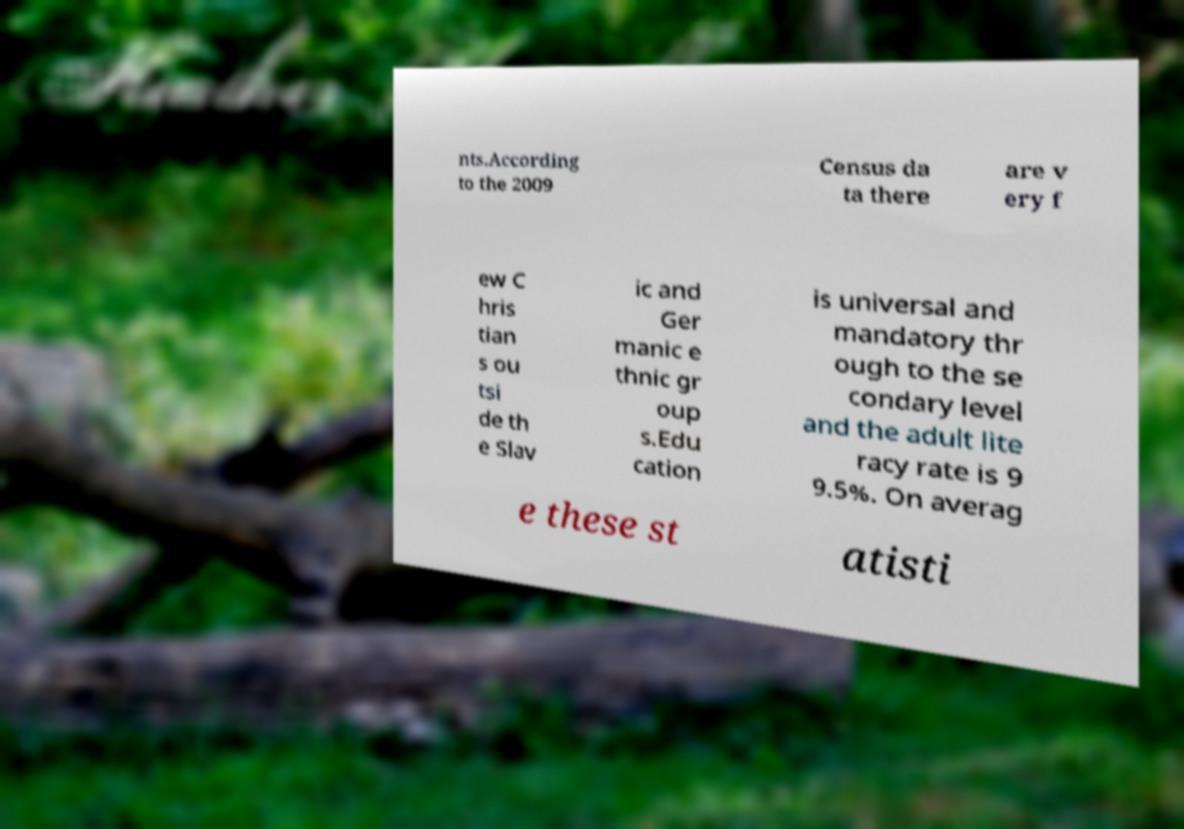Could you assist in decoding the text presented in this image and type it out clearly? nts.According to the 2009 Census da ta there are v ery f ew C hris tian s ou tsi de th e Slav ic and Ger manic e thnic gr oup s.Edu cation is universal and mandatory thr ough to the se condary level and the adult lite racy rate is 9 9.5%. On averag e these st atisti 